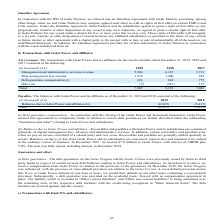According to Golar Lng's financial document, With which party did Golar Power closed their transaction with? According to the financial document, Stonepeak. The relevant text states: "onnection with the closing of the Golar Power and Stonepeak transaction, Golar Power entered into agreements to compensate Golar in relation to certain debt gu..." Also, In which years was the transactions recorded for? The document contains multiple relevant values: 2019, 2018, 2017. From the document: "(in thousands of $) 2019 2018 2017 Management and administrative services revenue 5,904 6,167 5,711 Ship management fees income 1,210 (in thousands of..." Also, What do Receivables and payables with Golar Power and its subsidiaries consist of? Comprised primarily of unpaid management fees, advisory and administrative services. The document states: "ayables with Golar Power and its subsidiaries are comprised primarily of unpaid management fees, advisory and administrative services. In addition, ce..." Additionally, Which year was the debt guarantee compensation the lowest? According to the financial document, 2019. The relevant text states: "(in thousands of $) 2019 2018 2017 Management and administrative services revenue 5,904 6,167 5,711 Ship management fees inc..." Also, can you calculate: What was the change in ship management fees income from 2017 to 2018? Based on the calculation: 1,400 - 824 , the result is 576 (in thousands). This is based on the information: "167 5,711 Ship management fees income 1,210 1,400 824 Debt guarantee compensation (i) 693 861 775 Other (ii) (2) (247) 135 Total 7,805 8,181 7,445 904 6,167 5,711 Ship management fees income 1,210 1,4..." The key data points involved are: 1,400, 824. Also, can you calculate: What was the percentage change in total transactions from 2018 to 2019? To answer this question, I need to perform calculations using the financial data. The calculation is: (7,805 - 8,181)/8,181 , which equals -4.6 (percentage). This is based on the information: "on (i) 693 861 775 Other (ii) (2) (247) 135 Total 7,805 8,181 7,445 693 861 775 Other (ii) (2) (247) 135 Total 7,805 8,181 7,445..." The key data points involved are: 7,805, 8,181. 